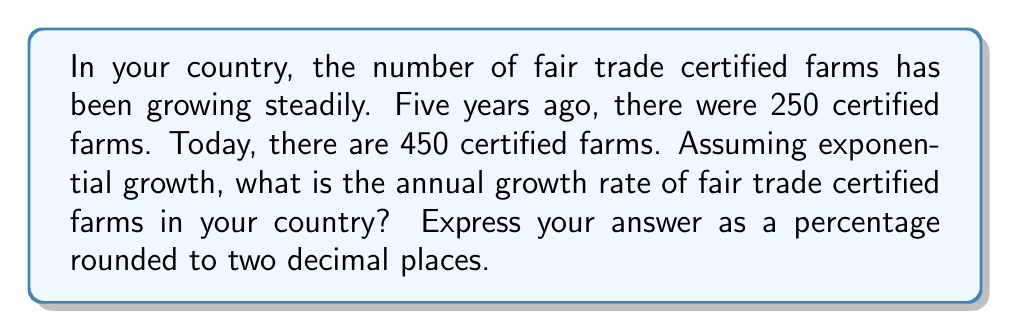Show me your answer to this math problem. To solve this problem, we'll use the exponential growth formula:

$$A = P(1 + r)^t$$

Where:
$A$ = Final amount (450 farms)
$P$ = Initial amount (250 farms)
$r$ = Annual growth rate (what we're solving for)
$t$ = Time period (5 years)

Let's plug in the values we know:

$$450 = 250(1 + r)^5$$

Now, let's solve for $r$:

1) Divide both sides by 250:
   $$\frac{450}{250} = (1 + r)^5$$

2) Simplify:
   $$1.8 = (1 + r)^5$$

3) Take the 5th root of both sides:
   $$\sqrt[5]{1.8} = 1 + r$$

4) Subtract 1 from both sides:
   $$\sqrt[5]{1.8} - 1 = r$$

5) Calculate:
   $$r \approx 0.1252$$

6) Convert to a percentage:
   $$r \approx 12.52\%$$
Answer: 12.52% 